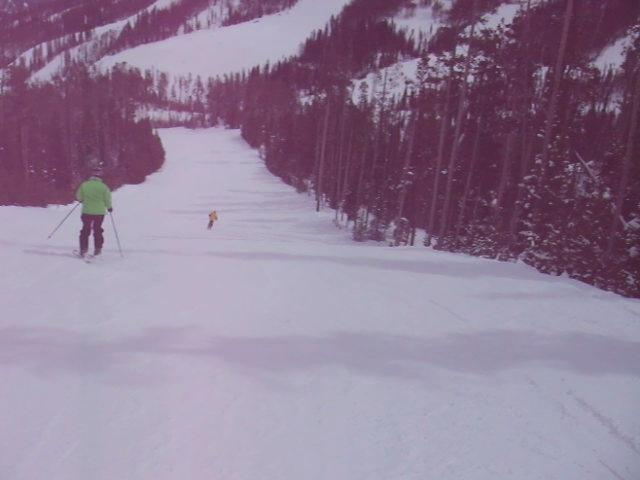What sport would this be if gates were added? Please explain your reasoning. moguls. Moguls are used for skiing and someone is skiing on a snowy mountain. 